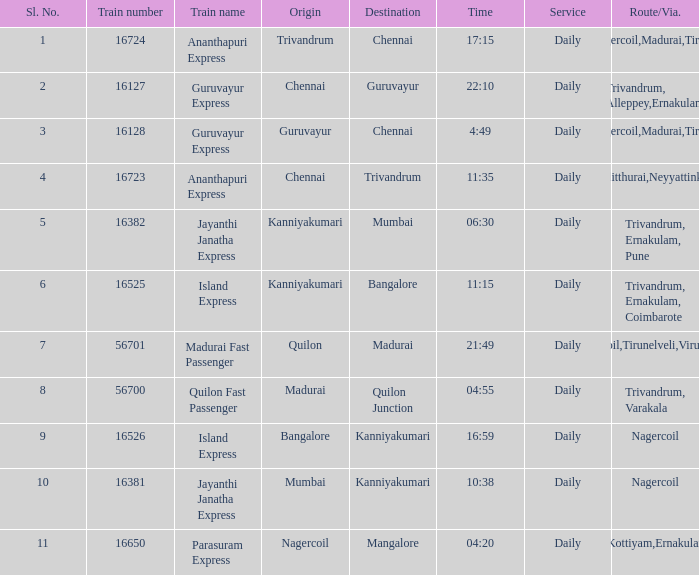What is the train number when the time is 10:38? 16381.0. 